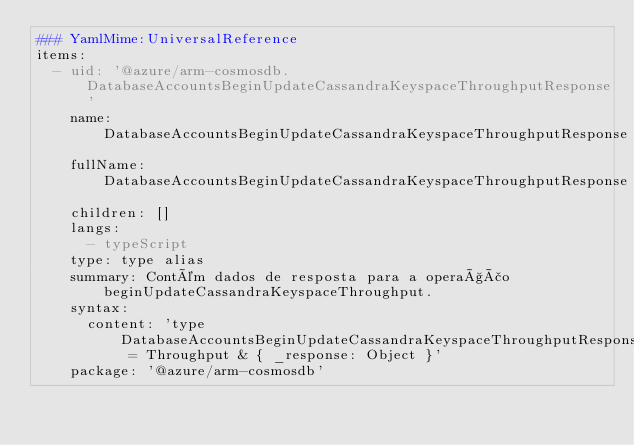<code> <loc_0><loc_0><loc_500><loc_500><_YAML_>### YamlMime:UniversalReference
items:
  - uid: '@azure/arm-cosmosdb.DatabaseAccountsBeginUpdateCassandraKeyspaceThroughputResponse'
    name: DatabaseAccountsBeginUpdateCassandraKeyspaceThroughputResponse
    fullName: DatabaseAccountsBeginUpdateCassandraKeyspaceThroughputResponse
    children: []
    langs:
      - typeScript
    type: type alias
    summary: Contém dados de resposta para a operação beginUpdateCassandraKeyspaceThroughput.
    syntax:
      content: 'type DatabaseAccountsBeginUpdateCassandraKeyspaceThroughputResponse = Throughput & { _response: Object }'
    package: '@azure/arm-cosmosdb'</code> 